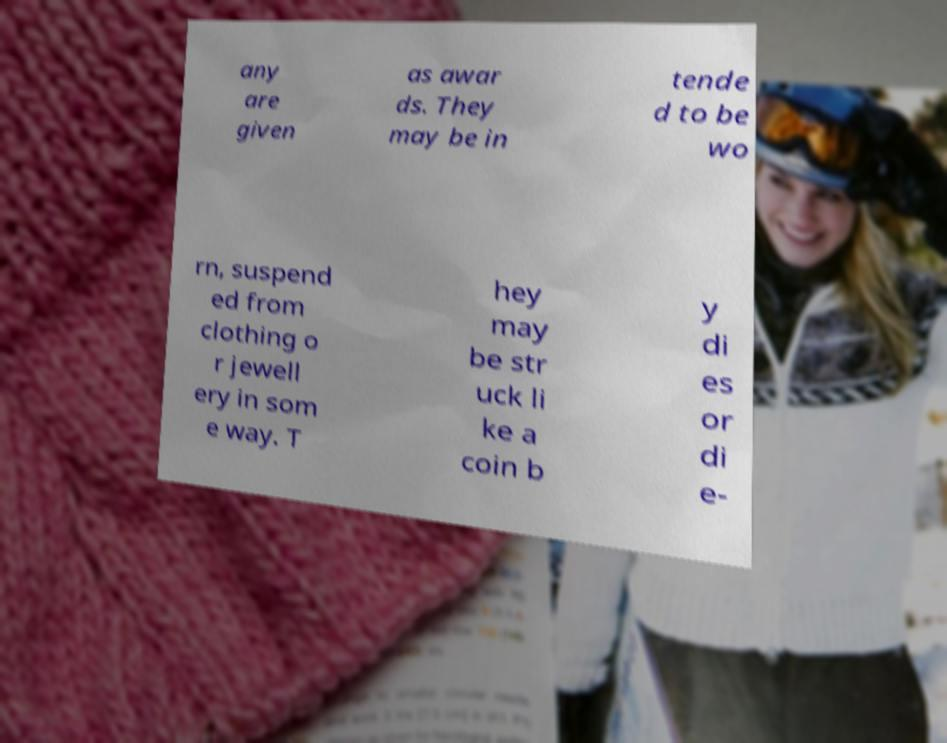What messages or text are displayed in this image? I need them in a readable, typed format. any are given as awar ds. They may be in tende d to be wo rn, suspend ed from clothing o r jewell ery in som e way. T hey may be str uck li ke a coin b y di es or di e- 